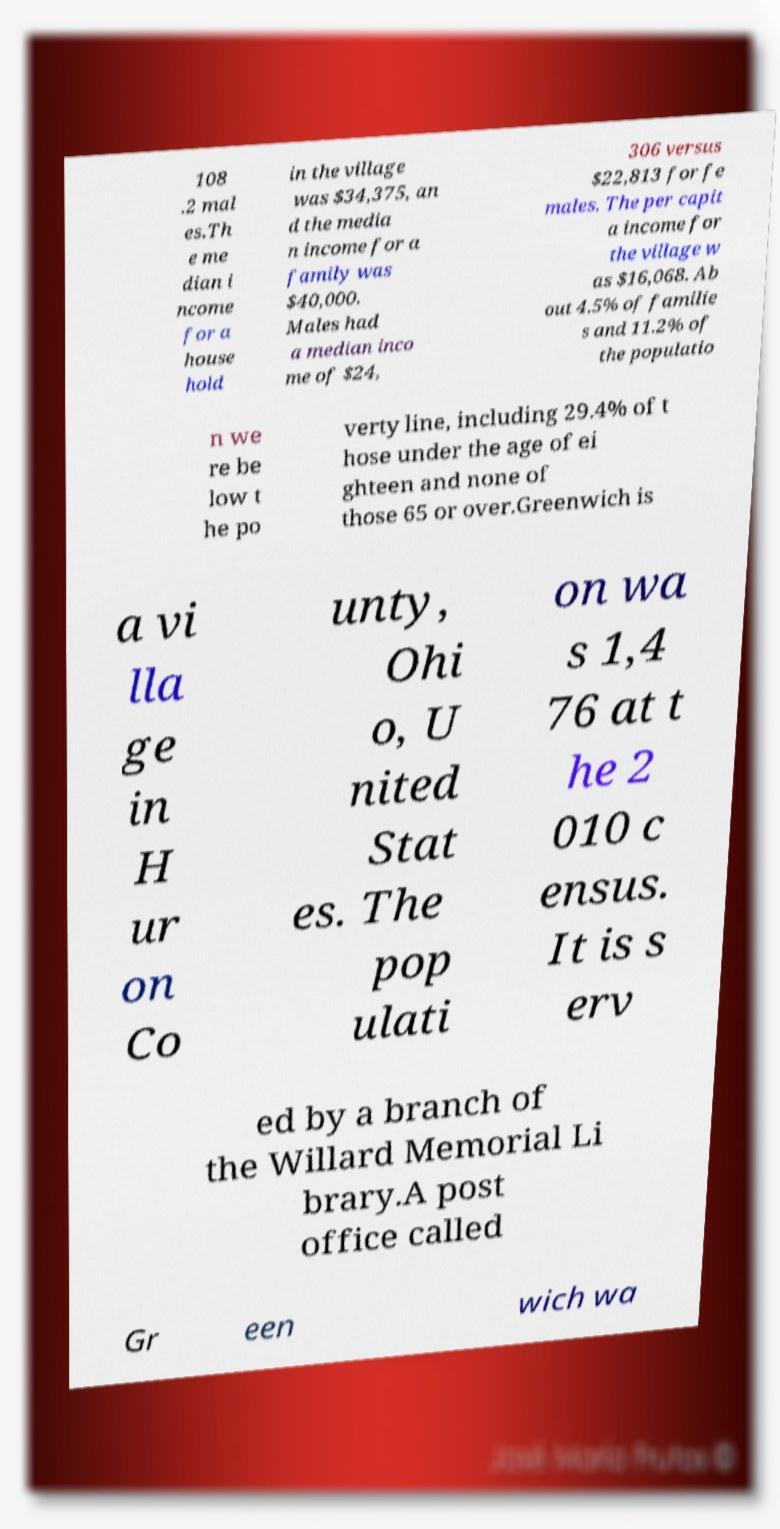For documentation purposes, I need the text within this image transcribed. Could you provide that? 108 .2 mal es.Th e me dian i ncome for a house hold in the village was $34,375, an d the media n income for a family was $40,000. Males had a median inco me of $24, 306 versus $22,813 for fe males. The per capit a income for the village w as $16,068. Ab out 4.5% of familie s and 11.2% of the populatio n we re be low t he po verty line, including 29.4% of t hose under the age of ei ghteen and none of those 65 or over.Greenwich is a vi lla ge in H ur on Co unty, Ohi o, U nited Stat es. The pop ulati on wa s 1,4 76 at t he 2 010 c ensus. It is s erv ed by a branch of the Willard Memorial Li brary.A post office called Gr een wich wa 